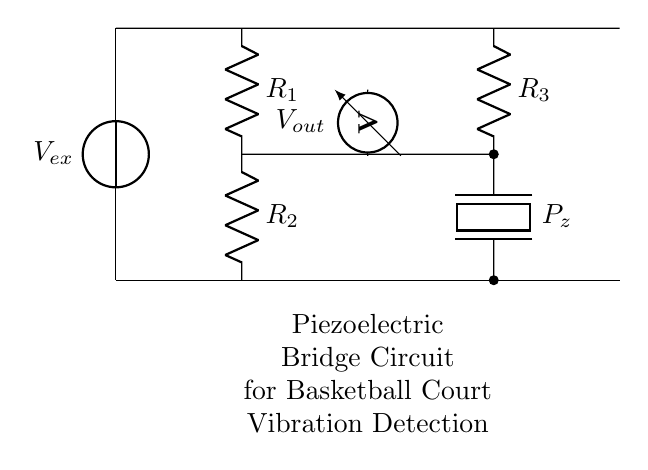What is the input voltage source labeled in the circuit? The input voltage source is labeled as Vex, which is shown on the left side of the circuit diagram.
Answer: Vex How many resistors are present in the circuit? There are three resistors in the circuit: R1, R2, and R3. The labels next to the components indicate their presence.
Answer: Three What type of sensor is indicated in the circuit? The circuit contains a piezoelectric sensor, denoted by the label Pz. This component is specifically designed for detecting vibrations.
Answer: Piezoelectric What is the purpose of the voltmeter in this circuit? The voltmeter is used to measure the output voltage, which is indicated by the label Vout. It is connected to the junction of the resistors and the piezoelectric element.
Answer: Measure output voltage If R1 is 100 ohms and R2 is 100 ohms, what is the equivalent resistance at their junction? R1 and R2 are in series, so the equivalent resistance is the sum of their resistances: 100 + 100 equals 200 ohms.
Answer: 200 ohms What happens to Vout if the piezoelectric element detects a vibration? When the piezoelectric element detects a vibration, it generates a change in voltage that will affect Vout. This is due to the piezoelectric effect converting mechanical strain into electrical signals.
Answer: Changes accordingly What is the configuration of this circuit? This circuit is configured as a bridge, specifically a piezoelectric bridge, used for measuring variations in mechanical properties due to vibrations.
Answer: Bridge 